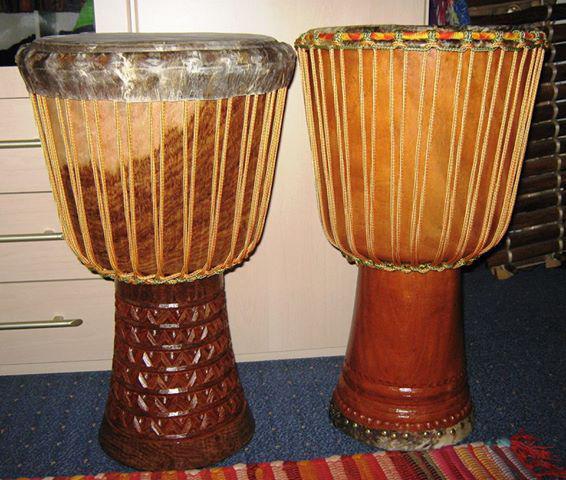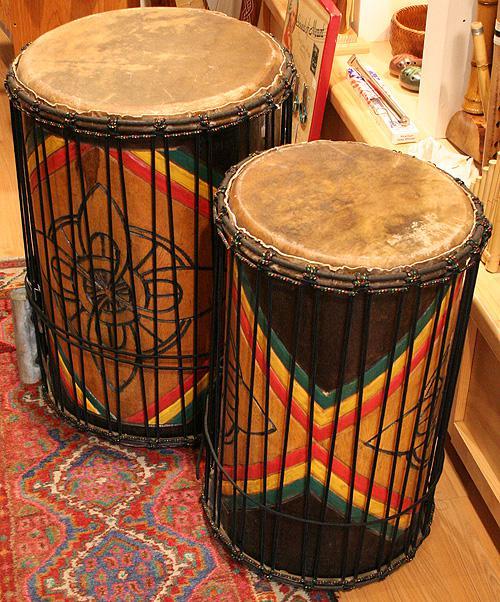The first image is the image on the left, the second image is the image on the right. For the images displayed, is the sentence "The left and right image contains the same number of drums." factually correct? Answer yes or no. Yes. The first image is the image on the left, the second image is the image on the right. Assess this claim about the two images: "The drums in each image are standing upright.". Correct or not? Answer yes or no. Yes. 